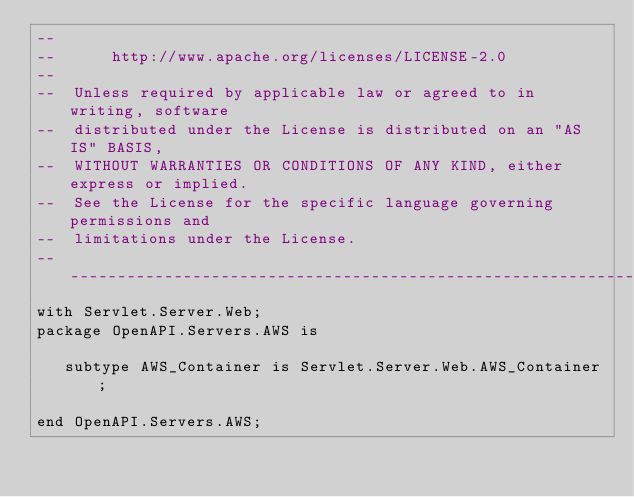Convert code to text. <code><loc_0><loc_0><loc_500><loc_500><_Ada_>--
--      http://www.apache.org/licenses/LICENSE-2.0
--
--  Unless required by applicable law or agreed to in writing, software
--  distributed under the License is distributed on an "AS IS" BASIS,
--  WITHOUT WARRANTIES OR CONDITIONS OF ANY KIND, either express or implied.
--  See the License for the specific language governing permissions and
--  limitations under the License.
-----------------------------------------------------------------------
with Servlet.Server.Web;
package OpenAPI.Servers.AWS is

   subtype AWS_Container is Servlet.Server.Web.AWS_Container;

end OpenAPI.Servers.AWS;
</code> 